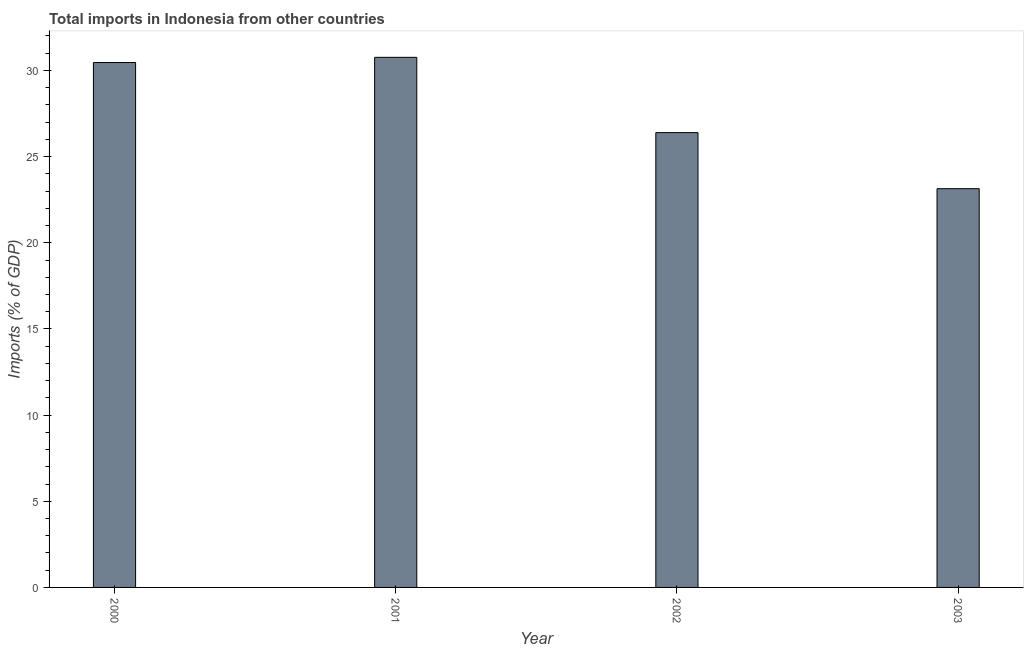Does the graph contain grids?
Your answer should be very brief. No. What is the title of the graph?
Ensure brevity in your answer.  Total imports in Indonesia from other countries. What is the label or title of the Y-axis?
Keep it short and to the point. Imports (% of GDP). What is the total imports in 2003?
Keep it short and to the point. 23.14. Across all years, what is the maximum total imports?
Your answer should be very brief. 30.76. Across all years, what is the minimum total imports?
Your answer should be compact. 23.14. In which year was the total imports maximum?
Keep it short and to the point. 2001. In which year was the total imports minimum?
Your answer should be compact. 2003. What is the sum of the total imports?
Offer a very short reply. 110.75. What is the difference between the total imports in 2000 and 2002?
Make the answer very short. 4.07. What is the average total imports per year?
Offer a very short reply. 27.69. What is the median total imports?
Keep it short and to the point. 28.43. Do a majority of the years between 2002 and 2000 (inclusive) have total imports greater than 5 %?
Your answer should be compact. Yes. Is the difference between the total imports in 2000 and 2003 greater than the difference between any two years?
Offer a very short reply. No. What is the difference between the highest and the second highest total imports?
Give a very brief answer. 0.3. What is the difference between the highest and the lowest total imports?
Keep it short and to the point. 7.62. How many bars are there?
Your answer should be very brief. 4. What is the difference between two consecutive major ticks on the Y-axis?
Provide a short and direct response. 5. Are the values on the major ticks of Y-axis written in scientific E-notation?
Give a very brief answer. No. What is the Imports (% of GDP) in 2000?
Ensure brevity in your answer.  30.46. What is the Imports (% of GDP) in 2001?
Give a very brief answer. 30.76. What is the Imports (% of GDP) of 2002?
Your answer should be compact. 26.39. What is the Imports (% of GDP) in 2003?
Provide a succinct answer. 23.14. What is the difference between the Imports (% of GDP) in 2000 and 2001?
Make the answer very short. -0.3. What is the difference between the Imports (% of GDP) in 2000 and 2002?
Your response must be concise. 4.07. What is the difference between the Imports (% of GDP) in 2000 and 2003?
Offer a very short reply. 7.32. What is the difference between the Imports (% of GDP) in 2001 and 2002?
Keep it short and to the point. 4.37. What is the difference between the Imports (% of GDP) in 2001 and 2003?
Your answer should be compact. 7.62. What is the difference between the Imports (% of GDP) in 2002 and 2003?
Make the answer very short. 3.25. What is the ratio of the Imports (% of GDP) in 2000 to that in 2001?
Offer a terse response. 0.99. What is the ratio of the Imports (% of GDP) in 2000 to that in 2002?
Give a very brief answer. 1.15. What is the ratio of the Imports (% of GDP) in 2000 to that in 2003?
Make the answer very short. 1.32. What is the ratio of the Imports (% of GDP) in 2001 to that in 2002?
Provide a succinct answer. 1.17. What is the ratio of the Imports (% of GDP) in 2001 to that in 2003?
Your answer should be very brief. 1.33. What is the ratio of the Imports (% of GDP) in 2002 to that in 2003?
Your response must be concise. 1.14. 